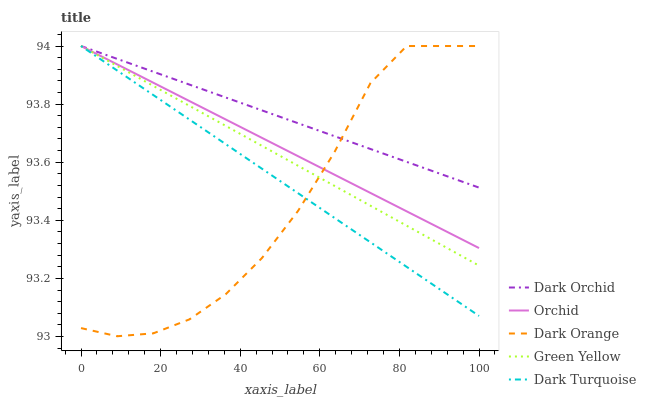Does Dark Orange have the minimum area under the curve?
Answer yes or no. Yes. Does Dark Orchid have the maximum area under the curve?
Answer yes or no. Yes. Does Green Yellow have the minimum area under the curve?
Answer yes or no. No. Does Green Yellow have the maximum area under the curve?
Answer yes or no. No. Is Dark Orchid the smoothest?
Answer yes or no. Yes. Is Dark Orange the roughest?
Answer yes or no. Yes. Is Green Yellow the smoothest?
Answer yes or no. No. Is Green Yellow the roughest?
Answer yes or no. No. Does Dark Orange have the lowest value?
Answer yes or no. Yes. Does Green Yellow have the lowest value?
Answer yes or no. No. Does Orchid have the highest value?
Answer yes or no. Yes. Does Orchid intersect Dark Turquoise?
Answer yes or no. Yes. Is Orchid less than Dark Turquoise?
Answer yes or no. No. Is Orchid greater than Dark Turquoise?
Answer yes or no. No. 